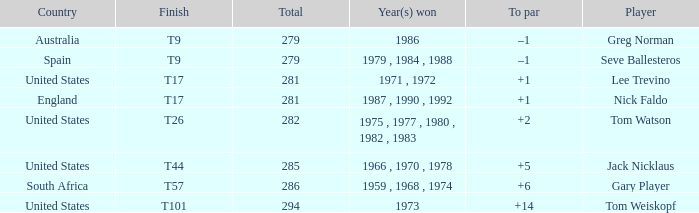What country is Greg Norman from? Australia. 